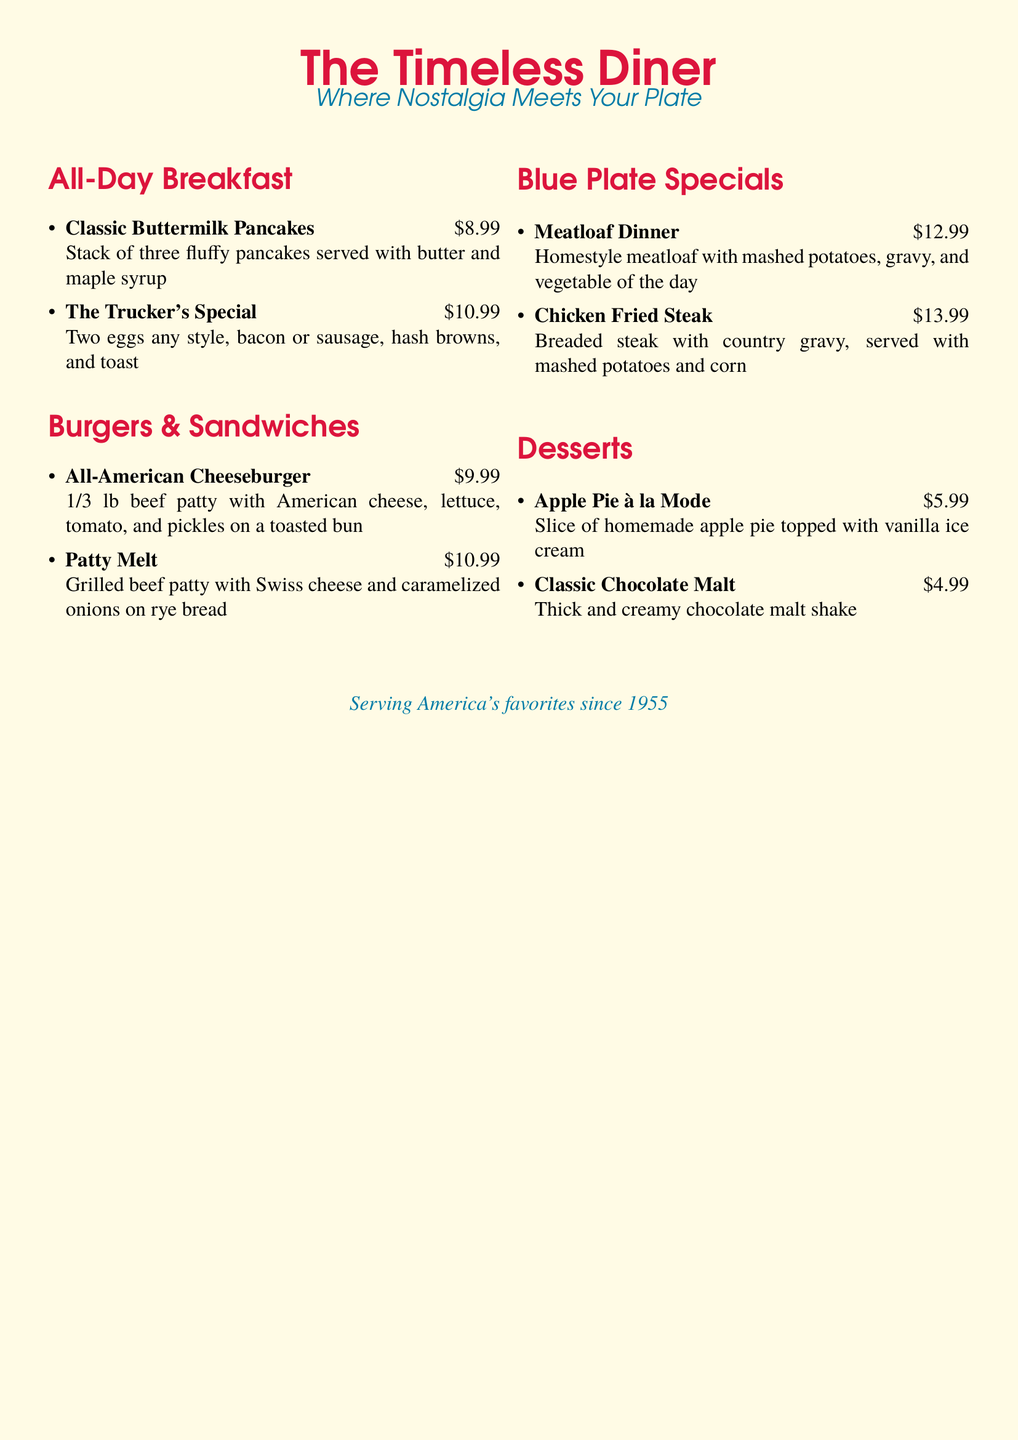What is the price of the Classic Buttermilk Pancakes? The price is listed under the All-Day Breakfast section as $8.99.
Answer: $8.99 How many items are in the Desserts section? By counting the items listed, there are two items mentioned under the Desserts section.
Answer: 2 What is included in The Trucker's Special? The description lists two eggs any style, bacon or sausage, hash browns, and toast.
Answer: Two eggs, bacon or sausage, hash browns, and toast What type of cheese is used in the Patty Melt? The menu specifies that Swiss cheese is used in the Patty Melt.
Answer: Swiss cheese Which dish has the highest price? The prices are compared, and Chicken Fried Steak at $13.99 is the highest.
Answer: Chicken Fried Steak What is the document highlighting as the theme? The tagline states "Where Nostalgia Meets Your Plate," indicating a nostalgic theme.
Answer: Nostalgia What year does the diner claim to have started serving favorites? The document states that America’s favorites have been served since 1955.
Answer: 1955 What is the total number of sections in the menu? Counting the sections listed in the menu, there are four main sections.
Answer: 4 What dessert features vanilla ice cream? The Apple Pie à la Mode is described as topped with vanilla ice cream.
Answer: Apple Pie à la Mode 